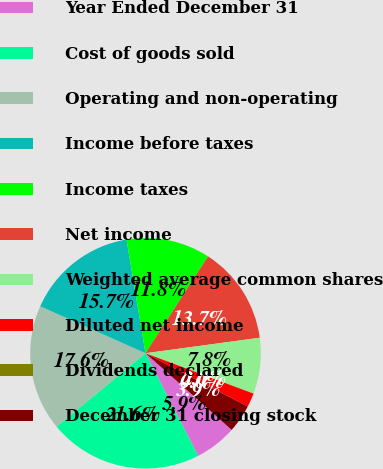Convert chart. <chart><loc_0><loc_0><loc_500><loc_500><pie_chart><fcel>Year Ended December 31<fcel>Cost of goods sold<fcel>Operating and non-operating<fcel>Income before taxes<fcel>Income taxes<fcel>Net income<fcel>Weighted average common shares<fcel>Diluted net income<fcel>Dividends declared<fcel>December 31 closing stock<nl><fcel>5.88%<fcel>21.57%<fcel>17.65%<fcel>15.69%<fcel>11.76%<fcel>13.73%<fcel>7.84%<fcel>1.96%<fcel>0.0%<fcel>3.92%<nl></chart> 